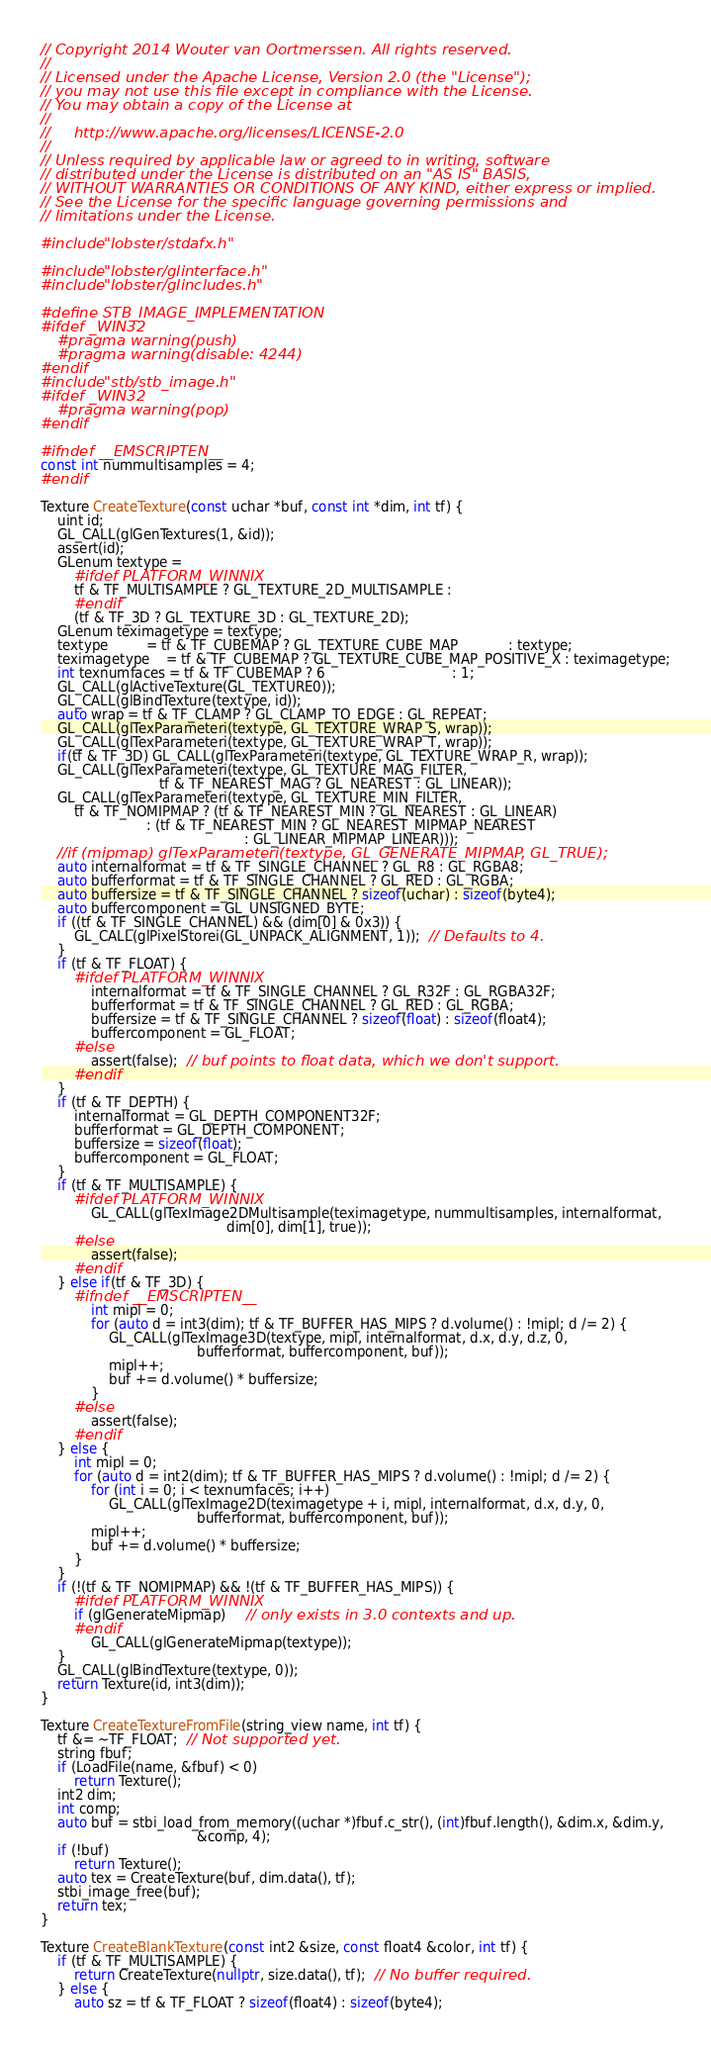<code> <loc_0><loc_0><loc_500><loc_500><_C++_>// Copyright 2014 Wouter van Oortmerssen. All rights reserved.
//
// Licensed under the Apache License, Version 2.0 (the "License");
// you may not use this file except in compliance with the License.
// You may obtain a copy of the License at
//
//     http://www.apache.org/licenses/LICENSE-2.0
//
// Unless required by applicable law or agreed to in writing, software
// distributed under the License is distributed on an "AS IS" BASIS,
// WITHOUT WARRANTIES OR CONDITIONS OF ANY KIND, either express or implied.
// See the License for the specific language governing permissions and
// limitations under the License.

#include "lobster/stdafx.h"

#include "lobster/glinterface.h"
#include "lobster/glincludes.h"

#define STB_IMAGE_IMPLEMENTATION
#ifdef _WIN32
    #pragma warning(push)
    #pragma warning(disable: 4244)
#endif
#include "stb/stb_image.h"
#ifdef _WIN32
    #pragma warning(pop)
#endif

#ifndef __EMSCRIPTEN__
const int nummultisamples = 4;
#endif

Texture CreateTexture(const uchar *buf, const int *dim, int tf) {
    uint id;
    GL_CALL(glGenTextures(1, &id));
    assert(id);
    GLenum textype =
        #ifdef PLATFORM_WINNIX
        tf & TF_MULTISAMPLE ? GL_TEXTURE_2D_MULTISAMPLE :
        #endif
        (tf & TF_3D ? GL_TEXTURE_3D : GL_TEXTURE_2D);
    GLenum teximagetype = textype;
    textype         = tf & TF_CUBEMAP ? GL_TEXTURE_CUBE_MAP            : textype;
    teximagetype    = tf & TF_CUBEMAP ? GL_TEXTURE_CUBE_MAP_POSITIVE_X : teximagetype;
    int texnumfaces = tf & TF_CUBEMAP ? 6                              : 1;
    GL_CALL(glActiveTexture(GL_TEXTURE0));
    GL_CALL(glBindTexture(textype, id));
    auto wrap = tf & TF_CLAMP ? GL_CLAMP_TO_EDGE : GL_REPEAT;
    GL_CALL(glTexParameteri(textype, GL_TEXTURE_WRAP_S, wrap));
    GL_CALL(glTexParameteri(textype, GL_TEXTURE_WRAP_T, wrap));
    if(tf & TF_3D) GL_CALL(glTexParameteri(textype, GL_TEXTURE_WRAP_R, wrap));
    GL_CALL(glTexParameteri(textype, GL_TEXTURE_MAG_FILTER,
                            tf & TF_NEAREST_MAG ? GL_NEAREST : GL_LINEAR));
    GL_CALL(glTexParameteri(textype, GL_TEXTURE_MIN_FILTER,
        tf & TF_NOMIPMAP ? (tf & TF_NEAREST_MIN ? GL_NEAREST : GL_LINEAR)
                         : (tf & TF_NEAREST_MIN ? GL_NEAREST_MIPMAP_NEAREST
                                                : GL_LINEAR_MIPMAP_LINEAR)));
    //if (mipmap) glTexParameteri(textype, GL_GENERATE_MIPMAP, GL_TRUE);
    auto internalformat = tf & TF_SINGLE_CHANNEL ? GL_R8 : GL_RGBA8;
    auto bufferformat = tf & TF_SINGLE_CHANNEL ? GL_RED : GL_RGBA;
    auto buffersize = tf & TF_SINGLE_CHANNEL ? sizeof(uchar) : sizeof(byte4);
    auto buffercomponent = GL_UNSIGNED_BYTE;
    if ((tf & TF_SINGLE_CHANNEL) && (dim[0] & 0x3)) {
        GL_CALL(glPixelStorei(GL_UNPACK_ALIGNMENT, 1));  // Defaults to 4.
    }
    if (tf & TF_FLOAT) {
        #ifdef PLATFORM_WINNIX
            internalformat = tf & TF_SINGLE_CHANNEL ? GL_R32F : GL_RGBA32F;
            bufferformat = tf & TF_SINGLE_CHANNEL ? GL_RED : GL_RGBA;
            buffersize = tf & TF_SINGLE_CHANNEL ? sizeof(float) : sizeof(float4);
            buffercomponent = GL_FLOAT;
        #else
            assert(false);  // buf points to float data, which we don't support.
        #endif
    }
    if (tf & TF_DEPTH) {
        internalformat = GL_DEPTH_COMPONENT32F;
        bufferformat = GL_DEPTH_COMPONENT;
        buffersize = sizeof(float);
        buffercomponent = GL_FLOAT;
    }
    if (tf & TF_MULTISAMPLE) {
        #ifdef PLATFORM_WINNIX
            GL_CALL(glTexImage2DMultisample(teximagetype, nummultisamples, internalformat,
                                            dim[0], dim[1], true));
        #else
            assert(false);
        #endif
    } else if(tf & TF_3D) {
		#ifndef __EMSCRIPTEN__
			int mipl = 0;
			for (auto d = int3(dim); tf & TF_BUFFER_HAS_MIPS ? d.volume() : !mipl; d /= 2) {
				GL_CALL(glTexImage3D(textype, mipl, internalformat, d.x, d.y, d.z, 0,
									 bufferformat, buffercomponent, buf));
				mipl++;
				buf += d.volume() * buffersize;
			}
		#else
			assert(false);
		#endif
    } else {
        int mipl = 0;
        for (auto d = int2(dim); tf & TF_BUFFER_HAS_MIPS ? d.volume() : !mipl; d /= 2) {
            for (int i = 0; i < texnumfaces; i++)
                GL_CALL(glTexImage2D(teximagetype + i, mipl, internalformat, d.x, d.y, 0,
                                     bufferformat, buffercomponent, buf));
            mipl++;
            buf += d.volume() * buffersize;
        }
    }
    if (!(tf & TF_NOMIPMAP) && !(tf & TF_BUFFER_HAS_MIPS)) {
        #ifdef PLATFORM_WINNIX
        if (glGenerateMipmap)     // only exists in 3.0 contexts and up.
        #endif
            GL_CALL(glGenerateMipmap(textype));
    }
    GL_CALL(glBindTexture(textype, 0));
    return Texture(id, int3(dim));
}

Texture CreateTextureFromFile(string_view name, int tf) {
    tf &= ~TF_FLOAT;  // Not supported yet.
    string fbuf;
    if (LoadFile(name, &fbuf) < 0)
        return Texture();
    int2 dim;
    int comp;
    auto buf = stbi_load_from_memory((uchar *)fbuf.c_str(), (int)fbuf.length(), &dim.x, &dim.y,
                                     &comp, 4);
    if (!buf)
        return Texture();
    auto tex = CreateTexture(buf, dim.data(), tf);
    stbi_image_free(buf);
    return tex;
}

Texture CreateBlankTexture(const int2 &size, const float4 &color, int tf) {
    if (tf & TF_MULTISAMPLE) {
        return CreateTexture(nullptr, size.data(), tf);  // No buffer required.
    } else {
        auto sz = tf & TF_FLOAT ? sizeof(float4) : sizeof(byte4);</code> 